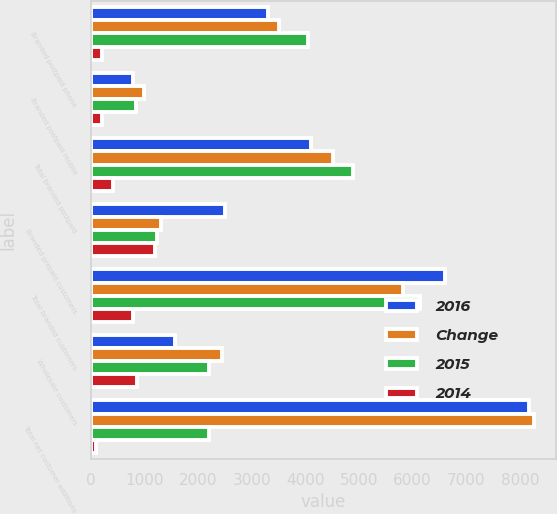Convert chart. <chart><loc_0><loc_0><loc_500><loc_500><stacked_bar_chart><ecel><fcel>Branded postpaid phone<fcel>Branded postpaid mobile<fcel>Total branded postpaid<fcel>Branded prepaid customers<fcel>Total branded customers<fcel>Wholesale customers<fcel>Total net customer additions<nl><fcel>2016<fcel>3307<fcel>790<fcel>4097<fcel>2508<fcel>6605<fcel>1568<fcel>8173<nl><fcel>Change<fcel>3511<fcel>999<fcel>4510<fcel>1315<fcel>5825<fcel>2439<fcel>8264<nl><fcel>2015<fcel>4047<fcel>839<fcel>4886<fcel>1244<fcel>6130<fcel>2204<fcel>2204<nl><fcel>2014<fcel>204<fcel>209<fcel>413<fcel>1193<fcel>780<fcel>871<fcel>91<nl></chart> 